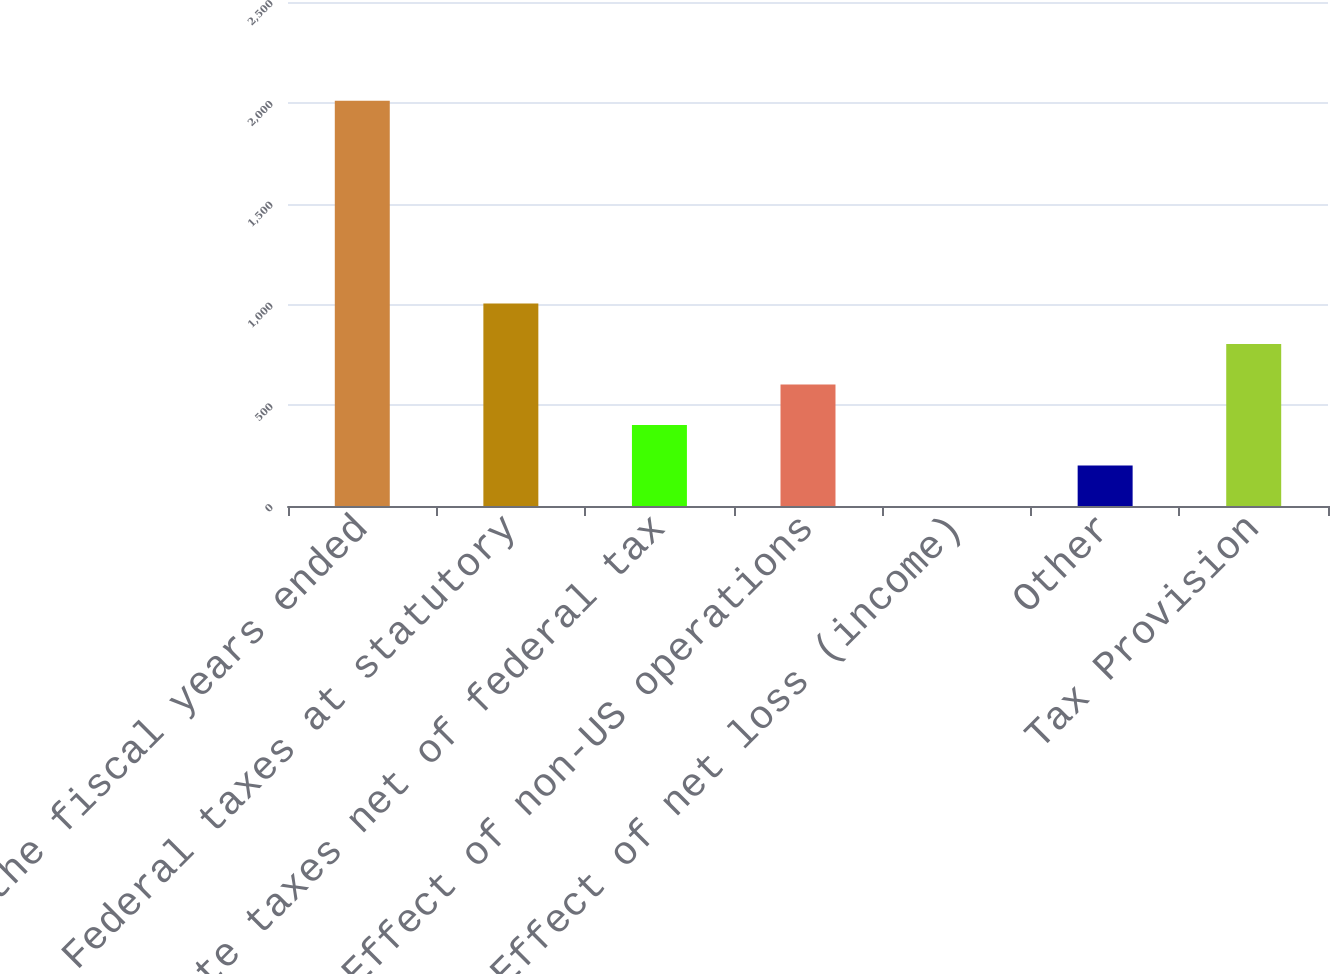Convert chart to OTSL. <chart><loc_0><loc_0><loc_500><loc_500><bar_chart><fcel>for the fiscal years ended<fcel>Federal taxes at statutory<fcel>State taxes net of federal tax<fcel>Effect of non-US operations<fcel>Effect of net loss (income)<fcel>Other<fcel>Tax Provision<nl><fcel>2010<fcel>1005.05<fcel>402.08<fcel>603.07<fcel>0.1<fcel>201.09<fcel>804.06<nl></chart> 